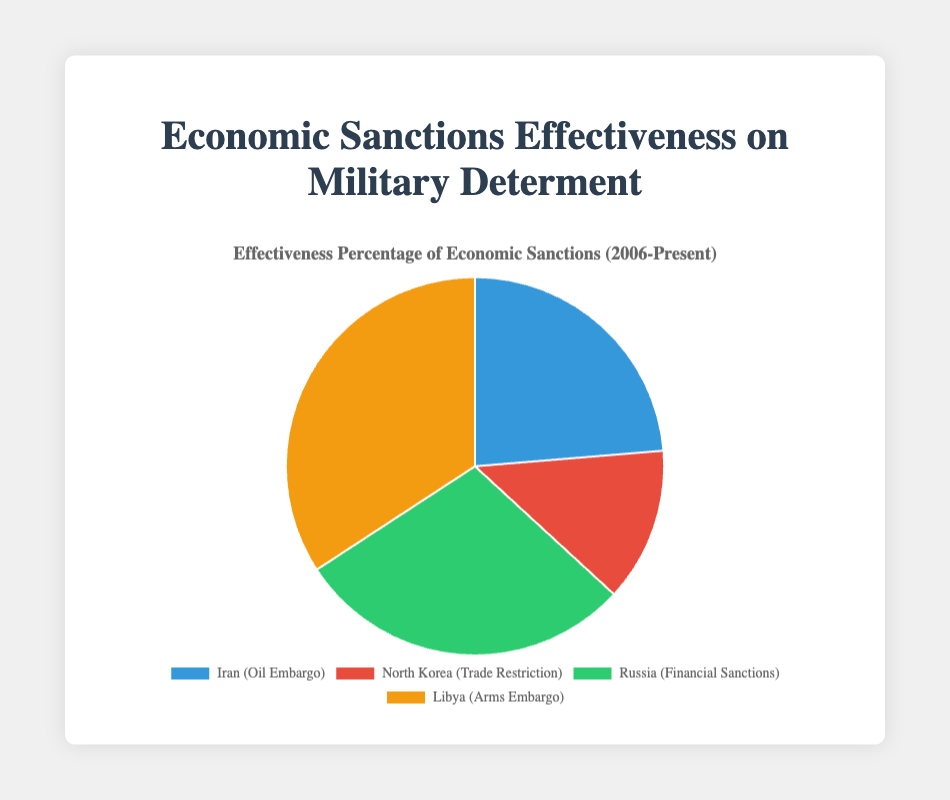Which country had the highest effectiveness percentage for economic sanctions? The figure shows the effectiveness of economic sanctions for each country. Libya has the highest effectiveness percentage with 65%.
Answer: Libya Which country had the lowest effectiveness percentage for economic sanctions? The chart indicates that North Korea had the lowest effectiveness percentage at 25%.
Answer: North Korea What is the average effectiveness percentage of the economic sanctions across all four countries? The effectiveness percentages are 45% (Iran), 25% (North Korea), 55% (Russia), and 65% (Libya). Add these values to get 190 and then divide by 4.
Answer: 47.5% What is the difference between the highest and lowest effectiveness percentages? Libya’s effectiveness is 65% and North Korea’s is 25%. The difference is 65% - 25%.
Answer: 40% Which color represents the country with the highest sanction effectiveness? According to the legend in the chart, Libya, which has the highest sanction effectiveness at 65%, is represented by the yellowish color.
Answer: Yellowish How does the effectiveness of Russia's financial sanctions compare to Iran's oil embargo? Russia's financial sanctions have an effectiveness of 55%, while Iran's oil embargo has 45%. Therefore, Russia's sanctions are 10% more effective.
Answer: Russia's sanctions are 10% more effective If we combine the percentages for Iran and North Korea, what do we get? Iran has 45% effectiveness and North Korea has 25%. Adding these values gives 45% + 25%.
Answer: 70% What is the combined percentage of effectiveness for Libya and Russia? Libya has 65% effectiveness and Russia has 55%. Adding these values gives 65% + 55%.
Answer: 120% What fraction of the total effectiveness percentage does North Korea represent? The total effectiveness percentage is 190% (sum of all countries' percentages). North Korea has 25%, so the fraction is 25/190. To simplify, we divide both numerator and denominator by 5, giving us 5/38.
Answer: 5/38 